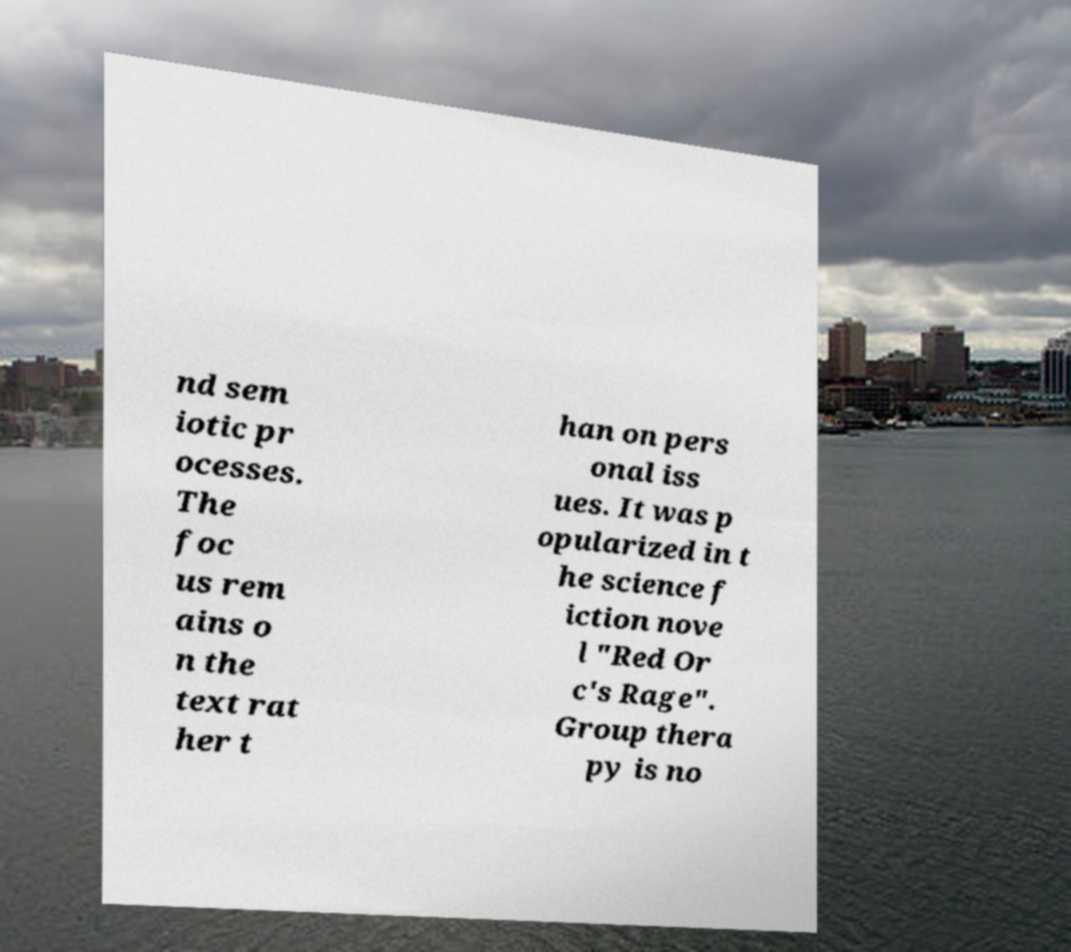Could you assist in decoding the text presented in this image and type it out clearly? nd sem iotic pr ocesses. The foc us rem ains o n the text rat her t han on pers onal iss ues. It was p opularized in t he science f iction nove l "Red Or c's Rage". Group thera py is no 